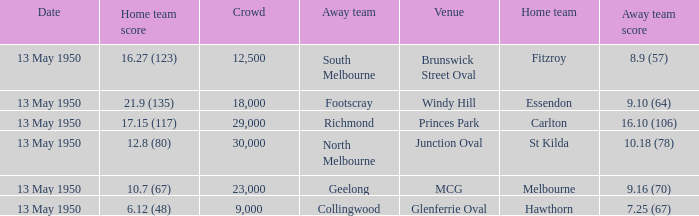What was the lowest crowd size at the Windy Hill venue? 18000.0. 